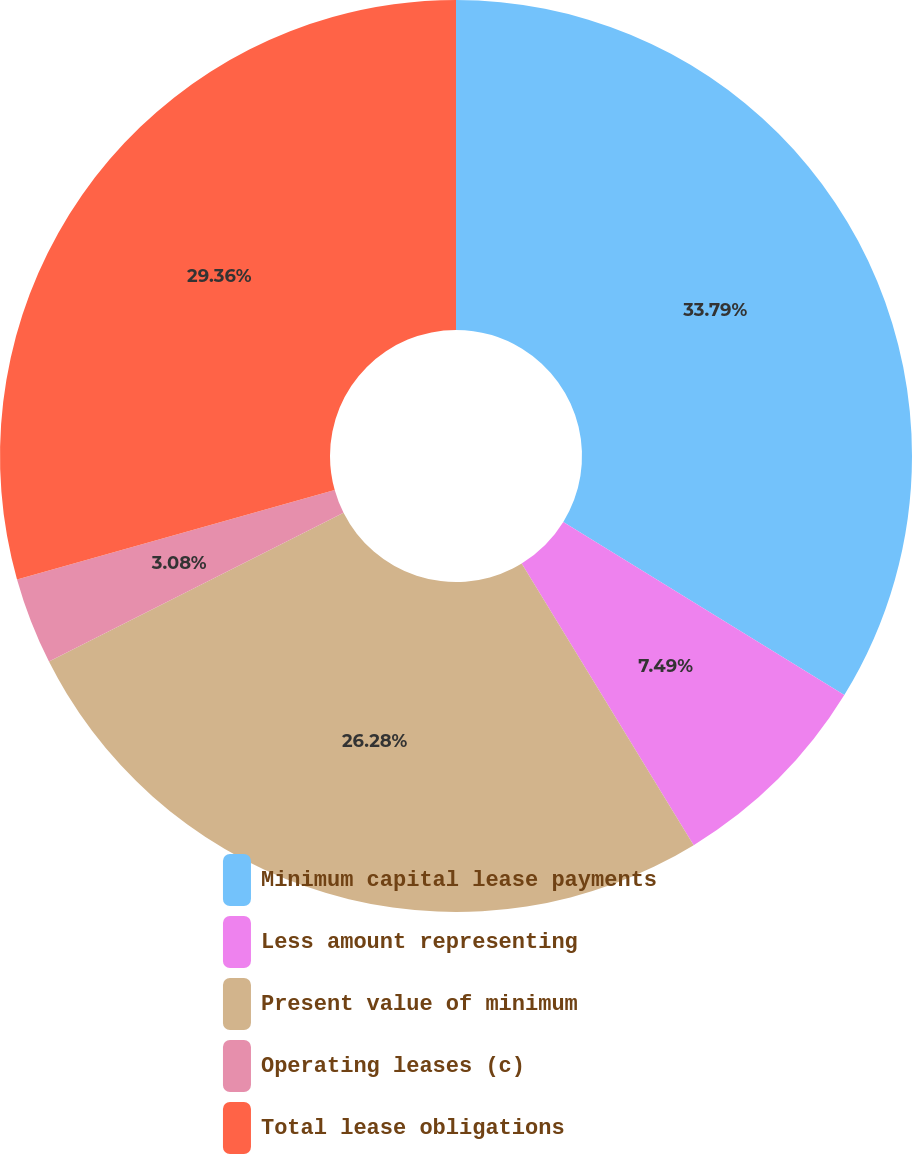<chart> <loc_0><loc_0><loc_500><loc_500><pie_chart><fcel>Minimum capital lease payments<fcel>Less amount representing<fcel>Present value of minimum<fcel>Operating leases (c)<fcel>Total lease obligations<nl><fcel>33.78%<fcel>7.49%<fcel>26.28%<fcel>3.08%<fcel>29.36%<nl></chart> 